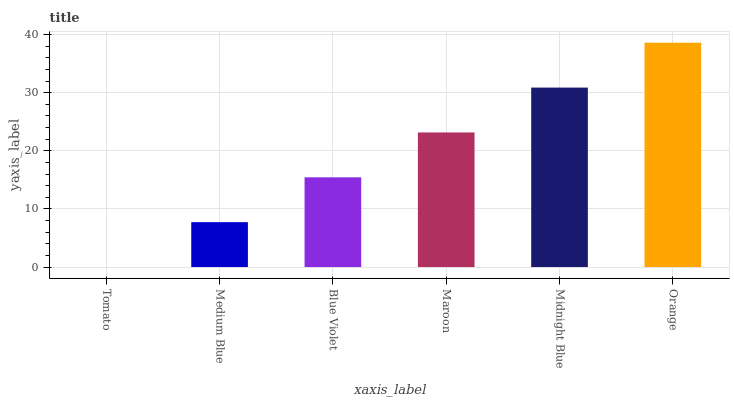Is Tomato the minimum?
Answer yes or no. Yes. Is Orange the maximum?
Answer yes or no. Yes. Is Medium Blue the minimum?
Answer yes or no. No. Is Medium Blue the maximum?
Answer yes or no. No. Is Medium Blue greater than Tomato?
Answer yes or no. Yes. Is Tomato less than Medium Blue?
Answer yes or no. Yes. Is Tomato greater than Medium Blue?
Answer yes or no. No. Is Medium Blue less than Tomato?
Answer yes or no. No. Is Maroon the high median?
Answer yes or no. Yes. Is Blue Violet the low median?
Answer yes or no. Yes. Is Blue Violet the high median?
Answer yes or no. No. Is Tomato the low median?
Answer yes or no. No. 